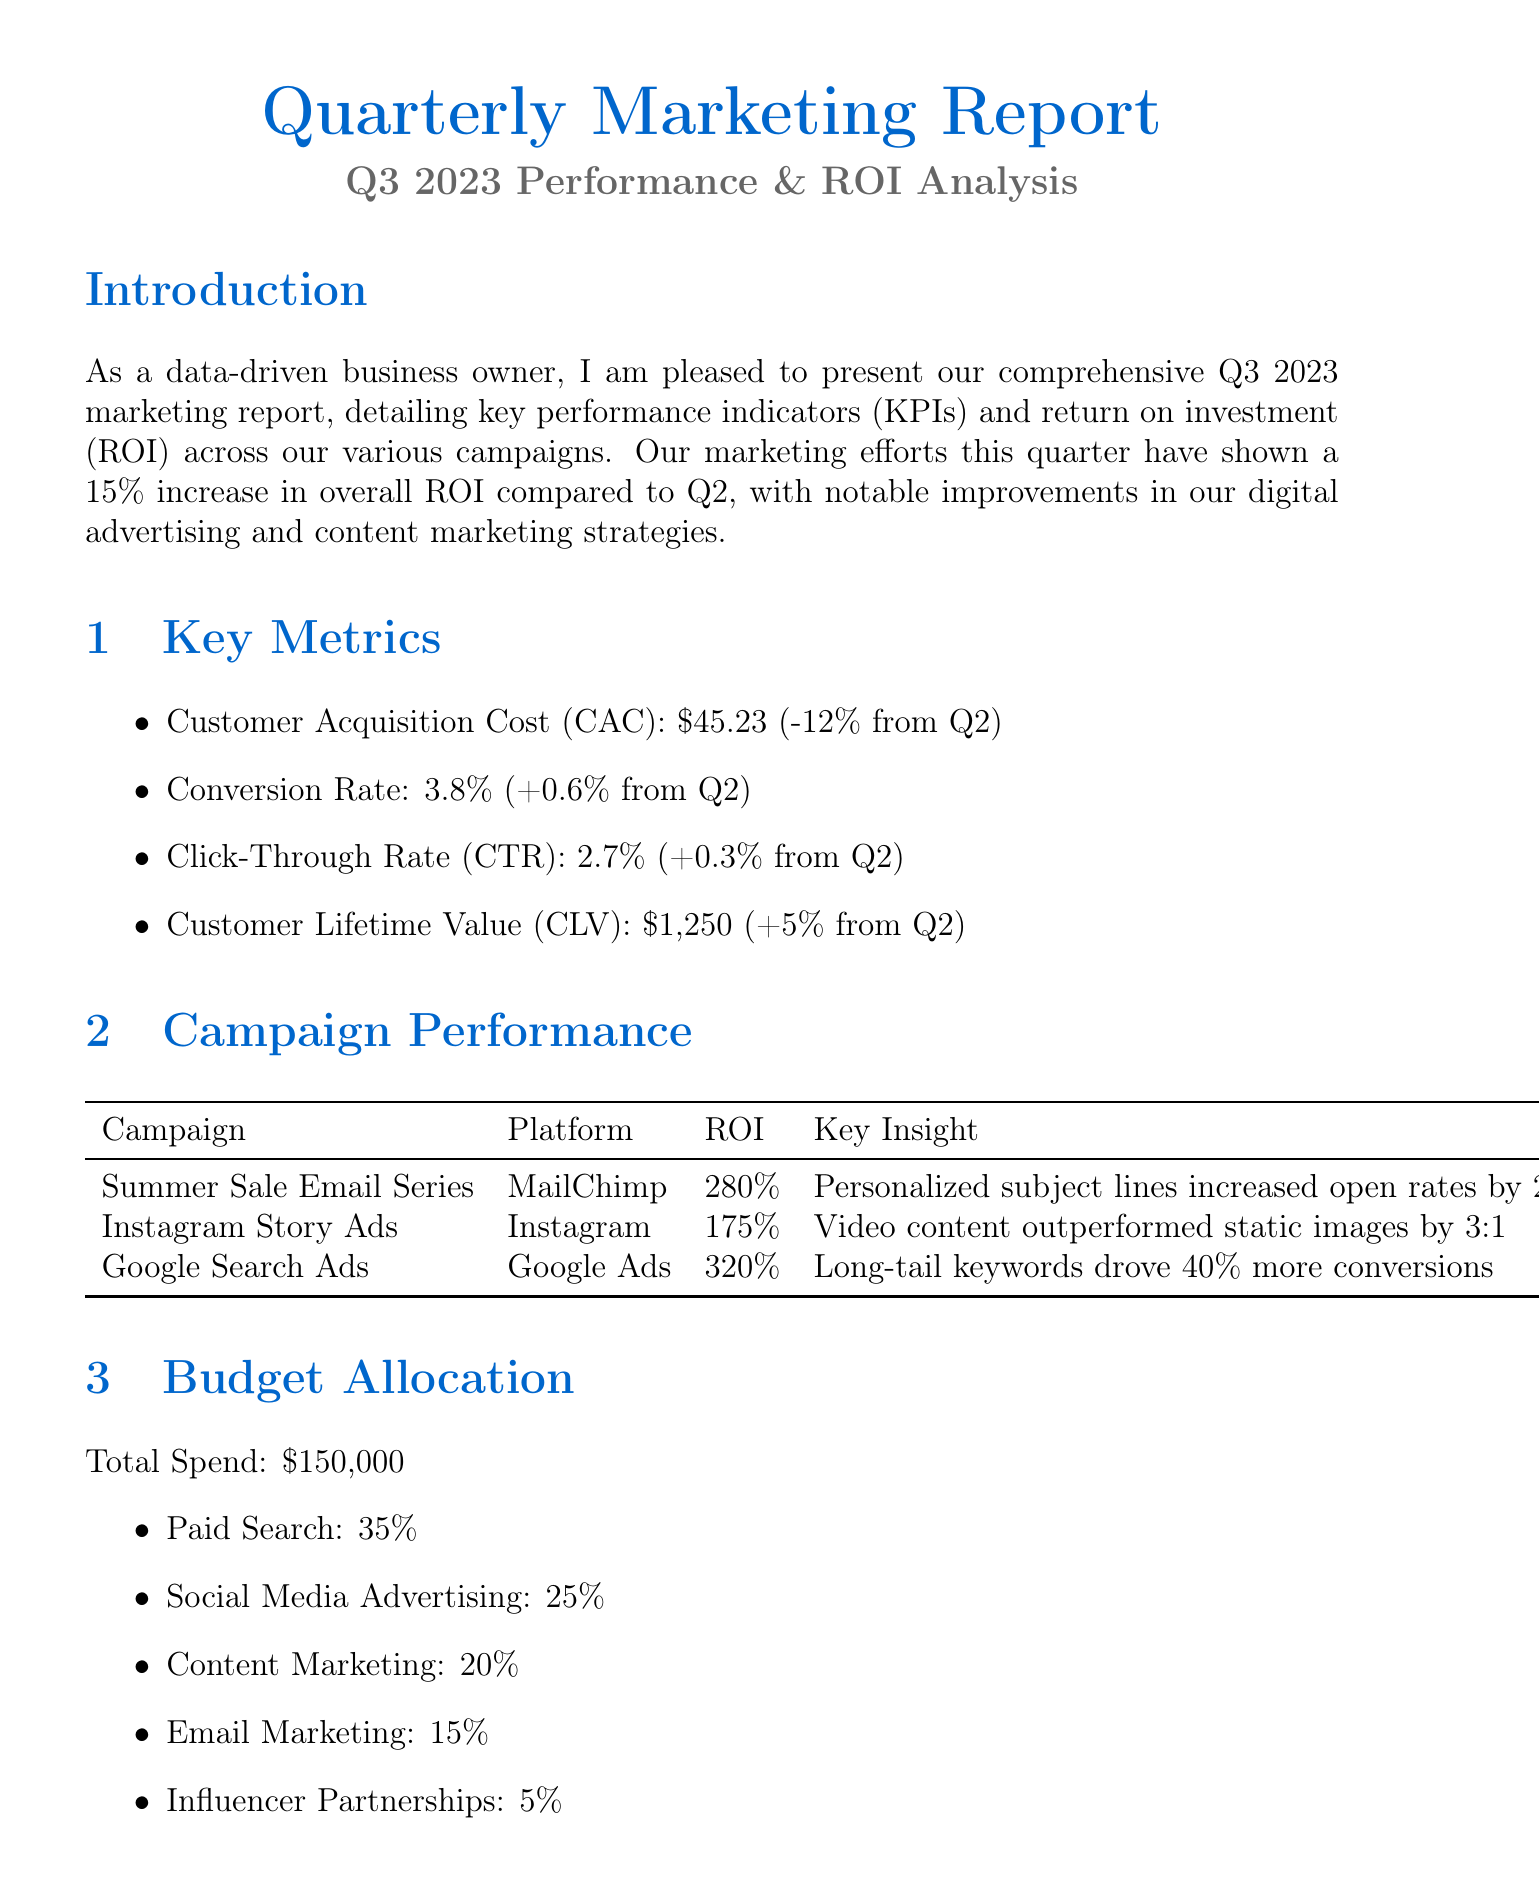What is the ROI for the Google Search Ads campaign? The ROI for the Google Search Ads campaign is mentioned in the campaign performance section of the document.
Answer: 320% What was the percentage change in Customer Acquisition Cost from Q2? The document provides a percentage change for Customer Acquisition Cost, which indicates the change from the previous quarter.
Answer: -12% Which customer segment had the highest revenue growth? The customer segment performance section indicates the growth percentages for different segments, and the highest growth is key information.
Answer: Millennial Fitness Enthusiasts What is the total marketing budget spent for Q3 2023? The total spend is clearly stated in the budget allocation section of the document.
Answer: $150,000 What will be the budget allocation increase for video content creation? Future plans for marketing are outlined, including changes in budget allocation, which is an important aspect of the document.
Answer: 10% 